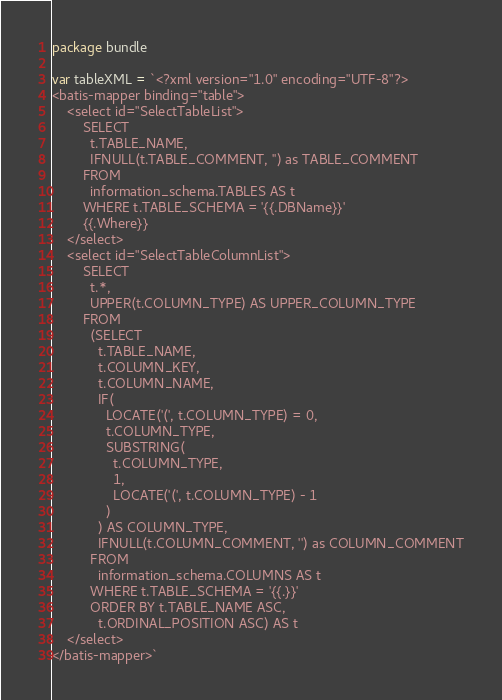Convert code to text. <code><loc_0><loc_0><loc_500><loc_500><_Go_>package bundle

var tableXML = `<?xml version="1.0" encoding="UTF-8"?>
<batis-mapper binding="table">
    <select id="SelectTableList">
		SELECT 
		  t.TABLE_NAME,
		  IFNULL(t.TABLE_COMMENT, '') as TABLE_COMMENT
		FROM
		  information_schema.TABLES AS t 
		WHERE t.TABLE_SCHEMA = '{{.DBName}}'
		{{.Where}}
    </select>
    <select id="SelectTableColumnList">
		SELECT 
		  t.*,
		  UPPER(t.COLUMN_TYPE) AS UPPER_COLUMN_TYPE 
		FROM
		  (SELECT 
			t.TABLE_NAME,
			t.COLUMN_KEY,
			t.COLUMN_NAME,
			IF(
			  LOCATE('(', t.COLUMN_TYPE) = 0,
			  t.COLUMN_TYPE,
			  SUBSTRING(
				t.COLUMN_TYPE,
				1,
				LOCATE('(', t.COLUMN_TYPE) - 1
			  )
			) AS COLUMN_TYPE,
			IFNULL(t.COLUMN_COMMENT, '') as COLUMN_COMMENT
		  FROM
			information_schema.COLUMNS AS t 
		  WHERE t.TABLE_SCHEMA = '{{.}}' 
		  ORDER BY t.TABLE_NAME ASC,
			t.ORDINAL_POSITION ASC) AS t 
    </select>
</batis-mapper>`
</code> 